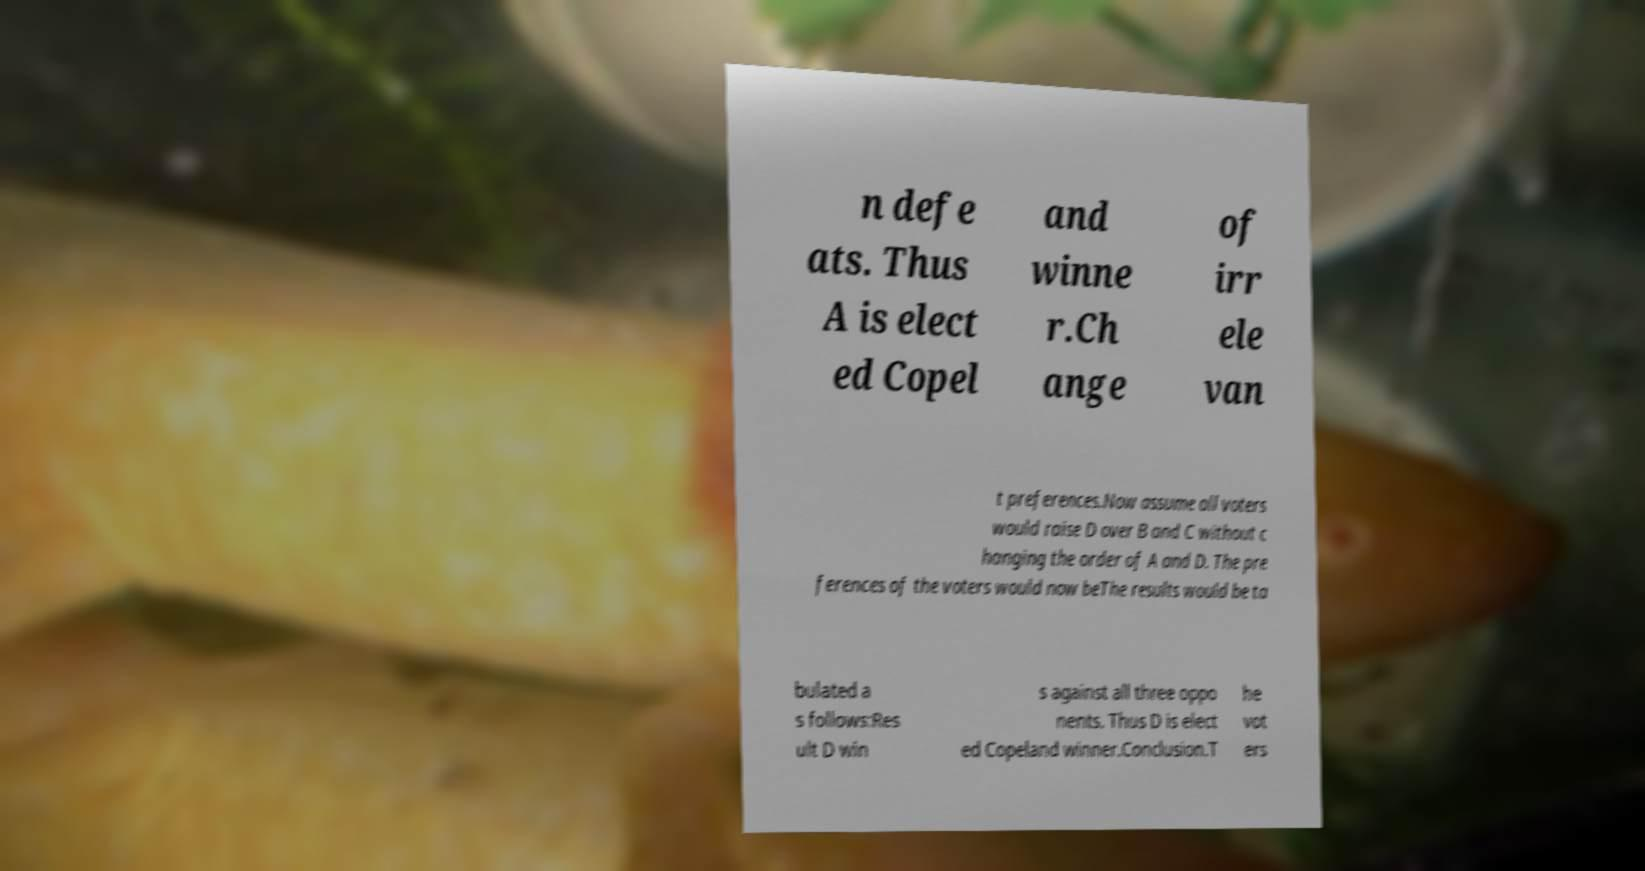Please identify and transcribe the text found in this image. n defe ats. Thus A is elect ed Copel and winne r.Ch ange of irr ele van t preferences.Now assume all voters would raise D over B and C without c hanging the order of A and D. The pre ferences of the voters would now beThe results would be ta bulated a s follows:Res ult D win s against all three oppo nents. Thus D is elect ed Copeland winner.Conclusion.T he vot ers 